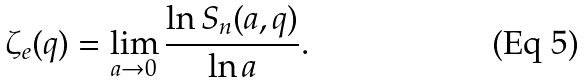<formula> <loc_0><loc_0><loc_500><loc_500>\zeta _ { e } ( q ) = \lim _ { a \rightarrow 0 } \frac { \ln S _ { n } ( a , q ) } { \ln a } .</formula> 